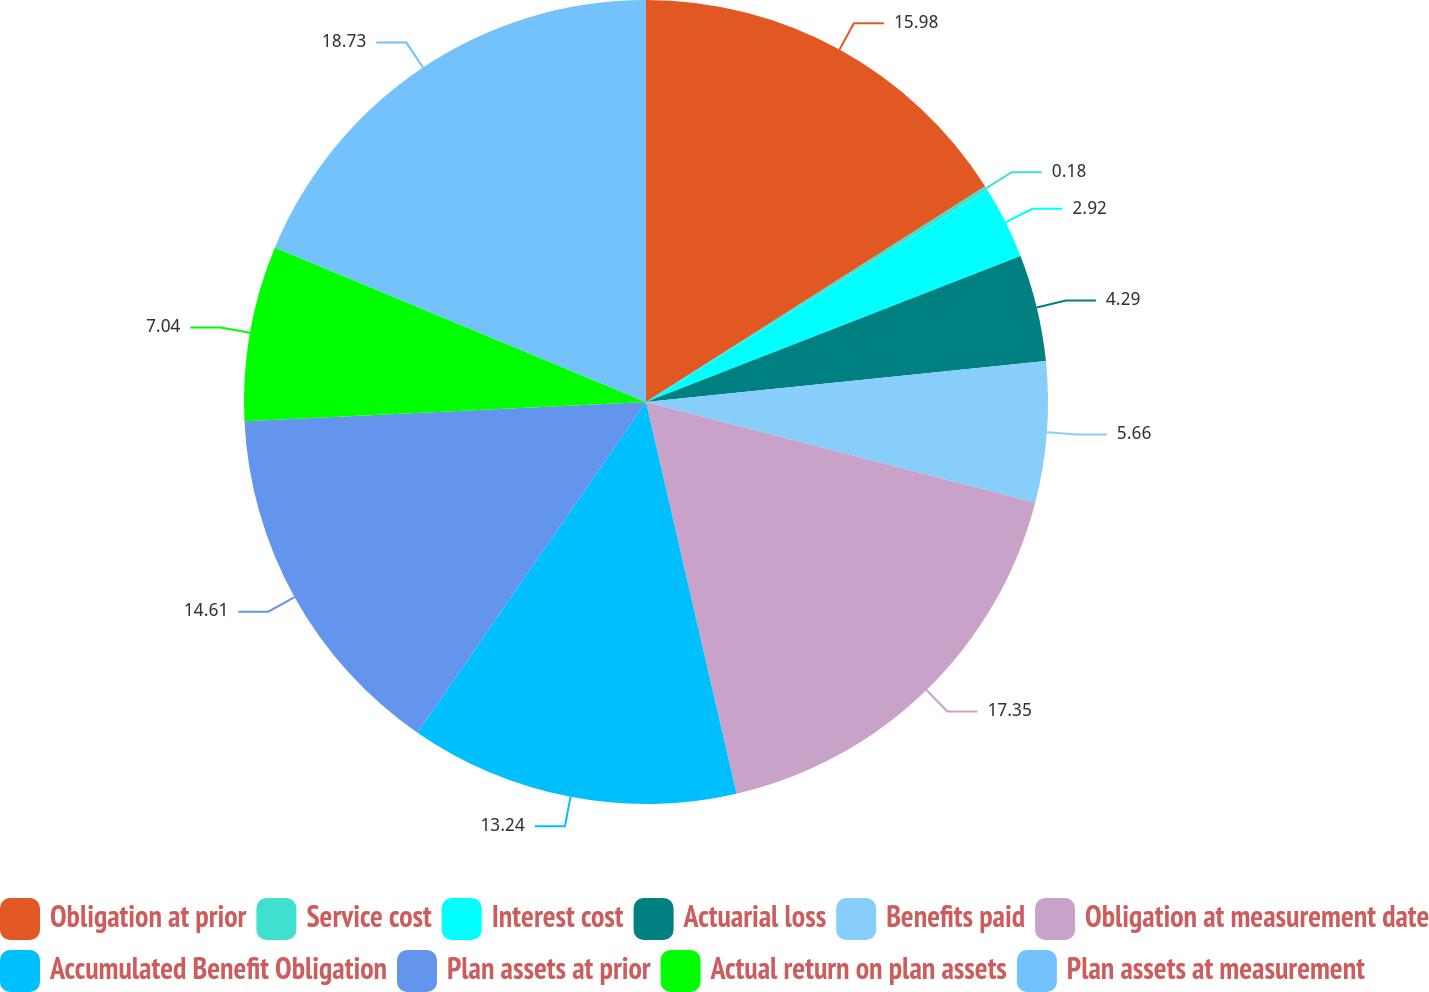<chart> <loc_0><loc_0><loc_500><loc_500><pie_chart><fcel>Obligation at prior<fcel>Service cost<fcel>Interest cost<fcel>Actuarial loss<fcel>Benefits paid<fcel>Obligation at measurement date<fcel>Accumulated Benefit Obligation<fcel>Plan assets at prior<fcel>Actual return on plan assets<fcel>Plan assets at measurement<nl><fcel>15.98%<fcel>0.18%<fcel>2.92%<fcel>4.29%<fcel>5.66%<fcel>17.35%<fcel>13.24%<fcel>14.61%<fcel>7.04%<fcel>18.72%<nl></chart> 